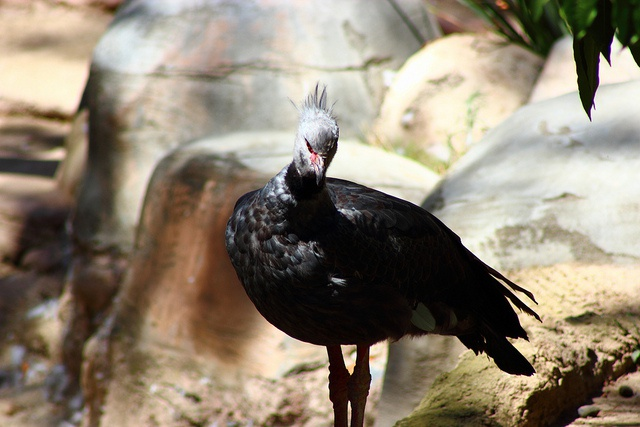Describe the objects in this image and their specific colors. I can see a bird in tan, black, gray, lightgray, and darkgray tones in this image. 